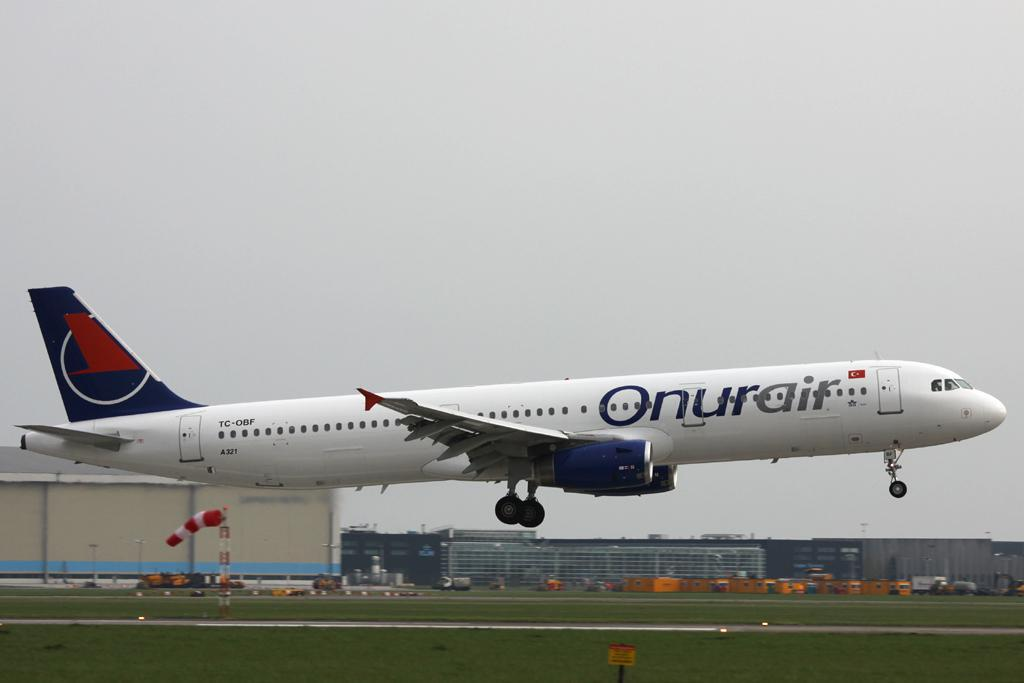<image>
Give a short and clear explanation of the subsequent image. A white Onurair plane is taking off from the airport 